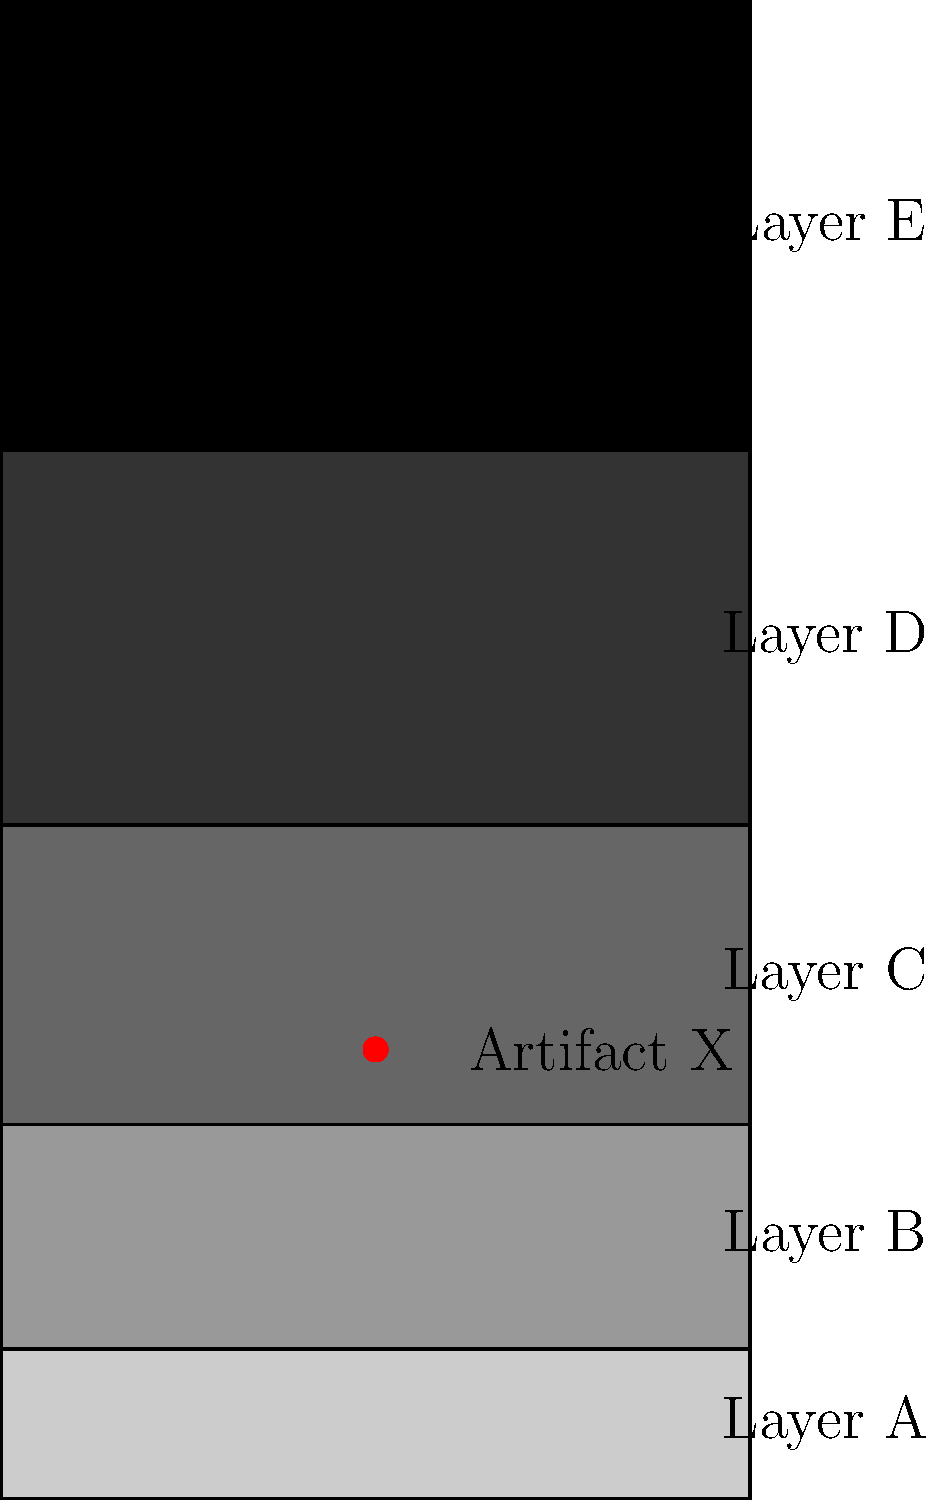As the lead archaeologist on this groundbreaking excavation, you've uncovered a unique artifact (X) in the stratigraphy shown. Based on the law of superposition and the artifact's location, which two layers were most likely deposited during the same archaeological period as the artifact? To answer this question, we need to apply the law of superposition and analyze the stratigraphy:

1. The law of superposition states that in undisturbed sedimentary layers, the oldest layers are at the bottom, and the youngest are at the top.

2. The stratigraphy shows five distinct layers, labeled A to E from bottom to top.

3. Artifact X is located in Layer C.

4. According to the law of superposition:
   - Layers A and B are older than the artifact
   - Layers D and E are younger than the artifact
   - Layer C, where the artifact is found, was deposited during the same period as the artifact

5. However, the question asks for two layers. We need to consider the possibility that the artifact could have been deposited at the very beginning or end of Layer C's formation.

6. If the artifact was deposited at the beginning of Layer C's formation, it would be contemporaneous with Layer B and the early part of Layer C.

7. If the artifact was deposited at the end of Layer C's formation, it would be contemporaneous with the late part of Layer C and Layer D.

8. Since we can't determine the exact timing within Layer C, we must consider both possibilities.

Therefore, the two layers most likely deposited during the same archaeological period as the artifact are Layer B and Layer D, which are immediately below and above Layer C, respectively.
Answer: Layers B and D 